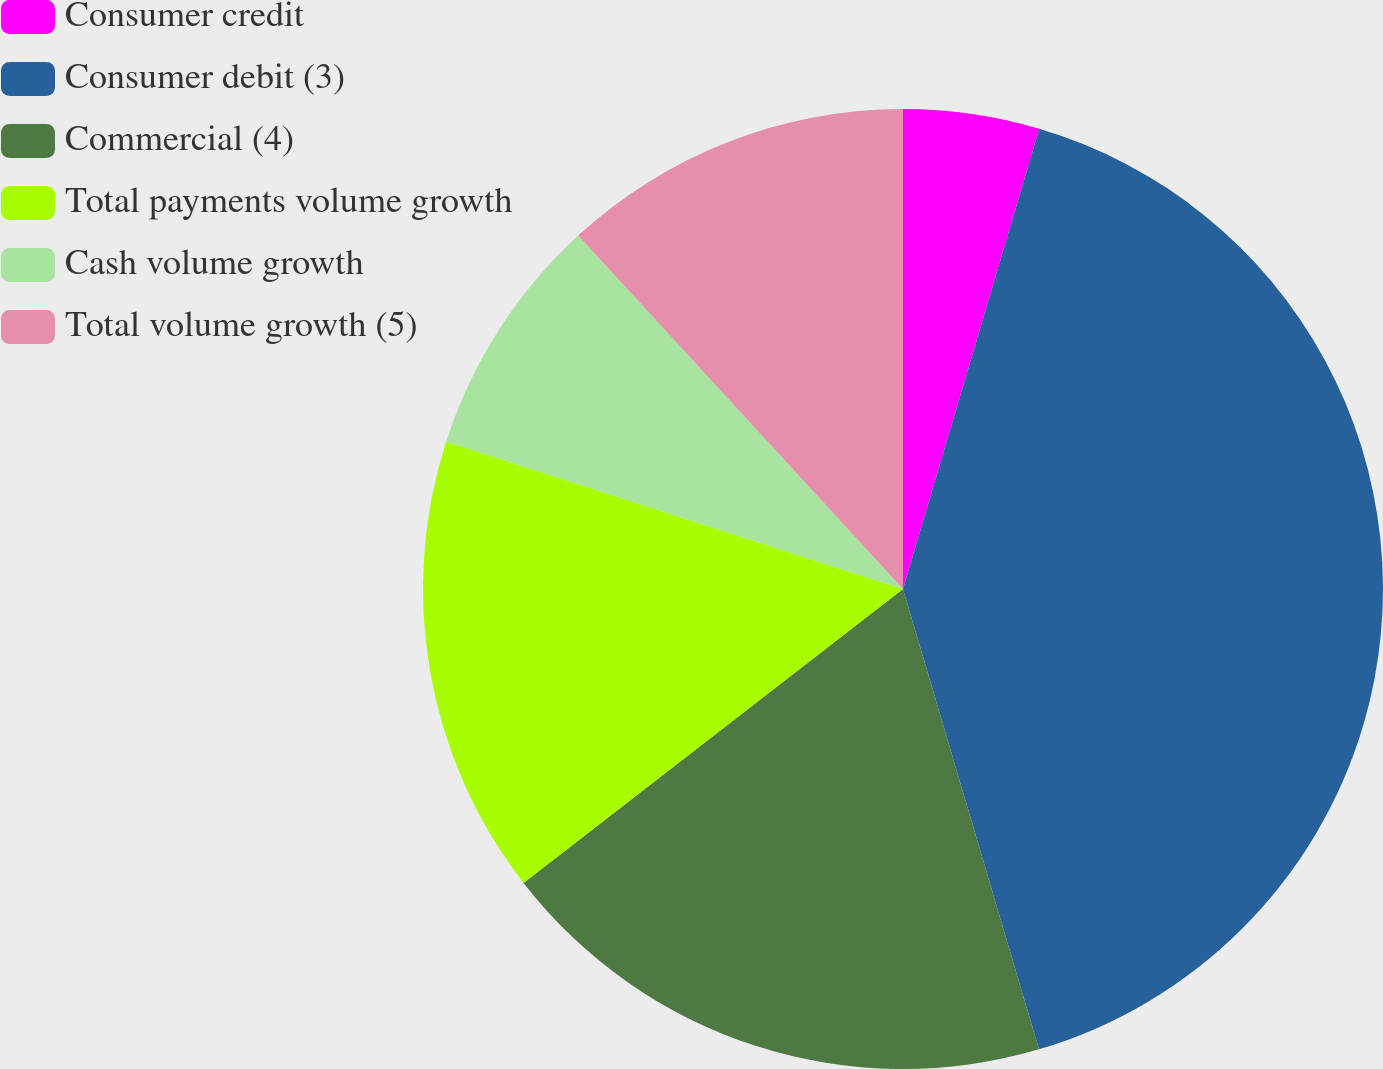Convert chart. <chart><loc_0><loc_0><loc_500><loc_500><pie_chart><fcel>Consumer credit<fcel>Consumer debit (3)<fcel>Commercial (4)<fcel>Total payments volume growth<fcel>Cash volume growth<fcel>Total volume growth (5)<nl><fcel>4.58%<fcel>40.85%<fcel>19.08%<fcel>15.46%<fcel>8.2%<fcel>11.83%<nl></chart> 